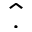<formula> <loc_0><loc_0><loc_500><loc_500>\hat { . }</formula> 